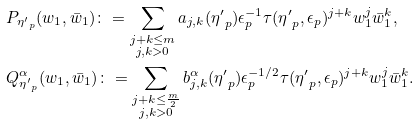Convert formula to latex. <formula><loc_0><loc_0><loc_500><loc_500>& P _ { { \eta ^ { \prime } } _ { p } } ( w _ { 1 } , \bar { w } _ { 1 } ) \colon = \sum _ { \substack { j + k \leq m \\ j , k > 0 } } a _ { j , k } ( { \eta ^ { \prime } } _ { p } ) \epsilon _ { p } ^ { - 1 } \tau ( { \eta ^ { \prime } } _ { p } , \epsilon _ { p } ) ^ { j + k } w _ { 1 } ^ { j } \bar { w } _ { 1 } ^ { k } , \\ & Q ^ { \alpha } _ { { \eta ^ { \prime } } _ { p } } ( w _ { 1 } , \bar { w } _ { 1 } ) \colon = \sum _ { \substack { j + k \leq \frac { m } { 2 } \\ j , k > 0 } } b ^ { \alpha } _ { j , k } ( { \eta ^ { \prime } } _ { p } ) \epsilon _ { p } ^ { - 1 / 2 } \tau ( { \eta ^ { \prime } } _ { p } , \epsilon _ { p } ) ^ { j + k } w _ { 1 } ^ { j } \bar { w } _ { 1 } ^ { k } .</formula> 